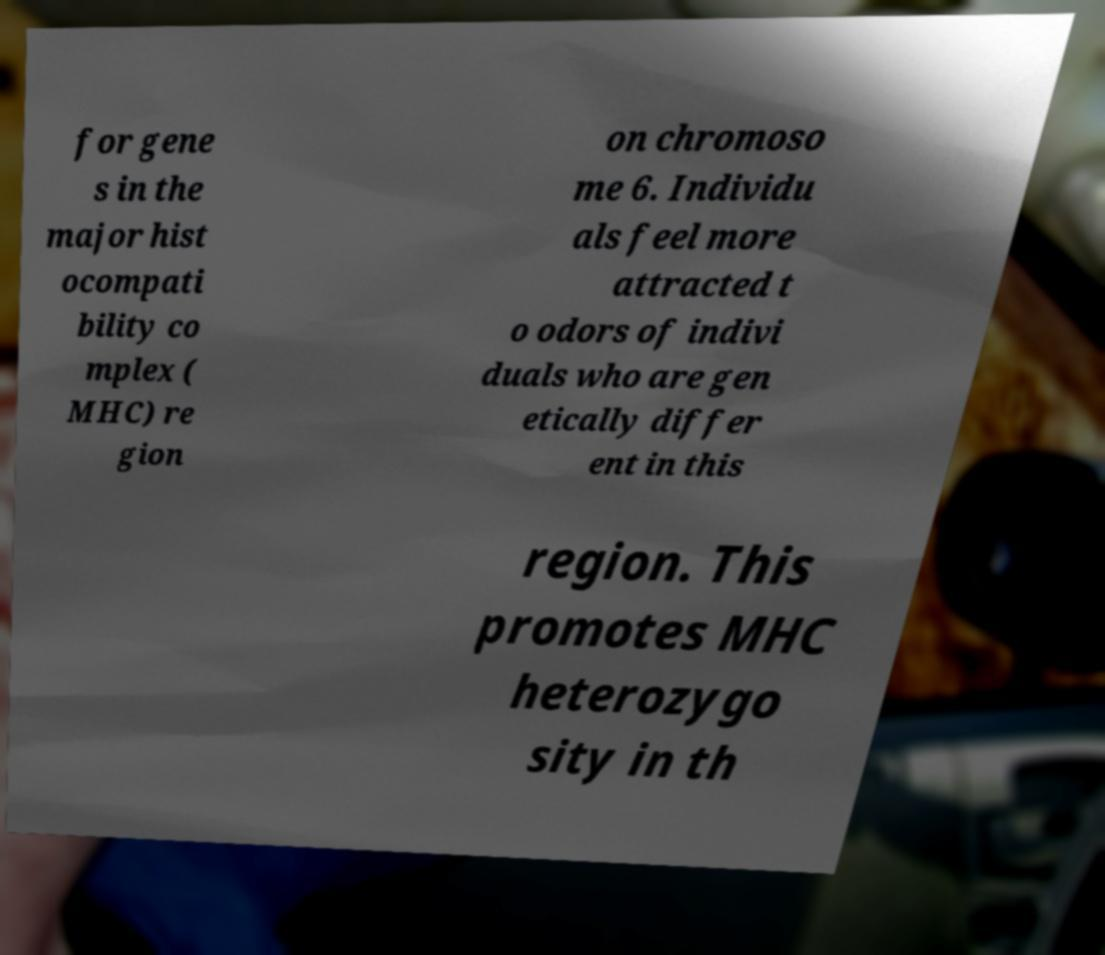Can you accurately transcribe the text from the provided image for me? for gene s in the major hist ocompati bility co mplex ( MHC) re gion on chromoso me 6. Individu als feel more attracted t o odors of indivi duals who are gen etically differ ent in this region. This promotes MHC heterozygo sity in th 